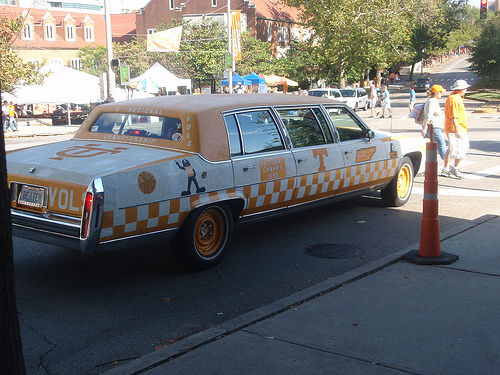<image>
Is the cone to the right of the car? Yes. From this viewpoint, the cone is positioned to the right side relative to the car. 